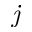<formula> <loc_0><loc_0><loc_500><loc_500>j</formula> 